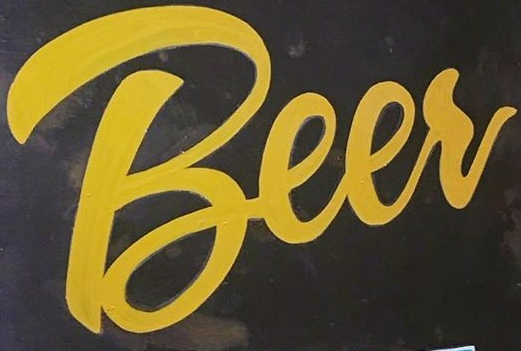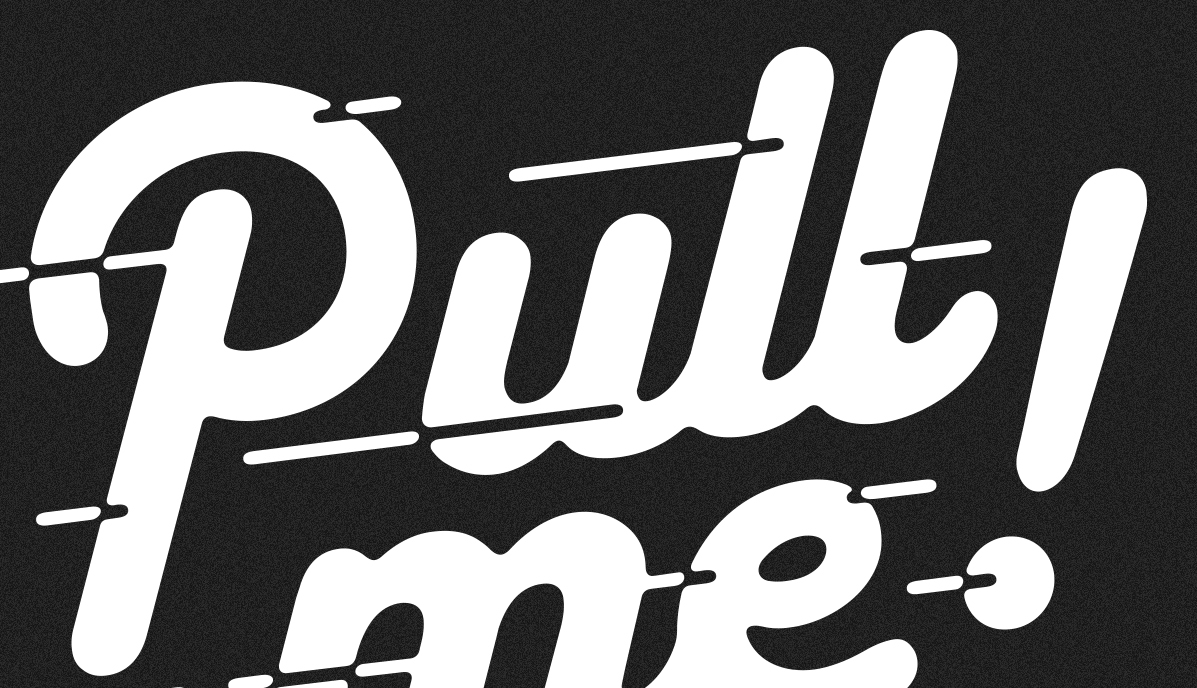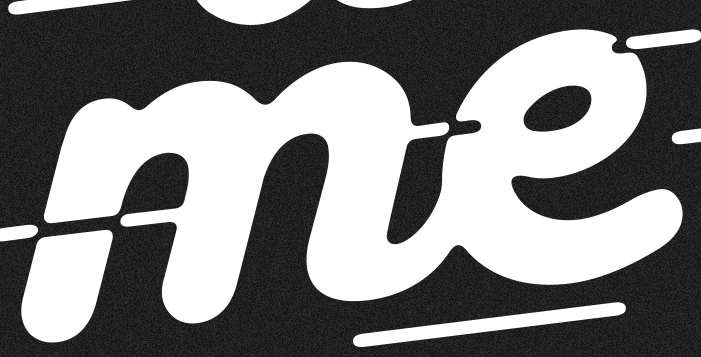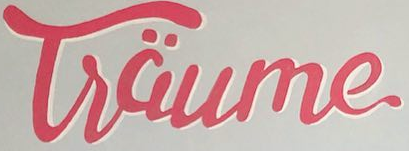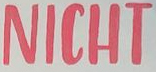Transcribe the words shown in these images in order, separated by a semicolon. Beer; pull!; me; Tsäume; NICHT 